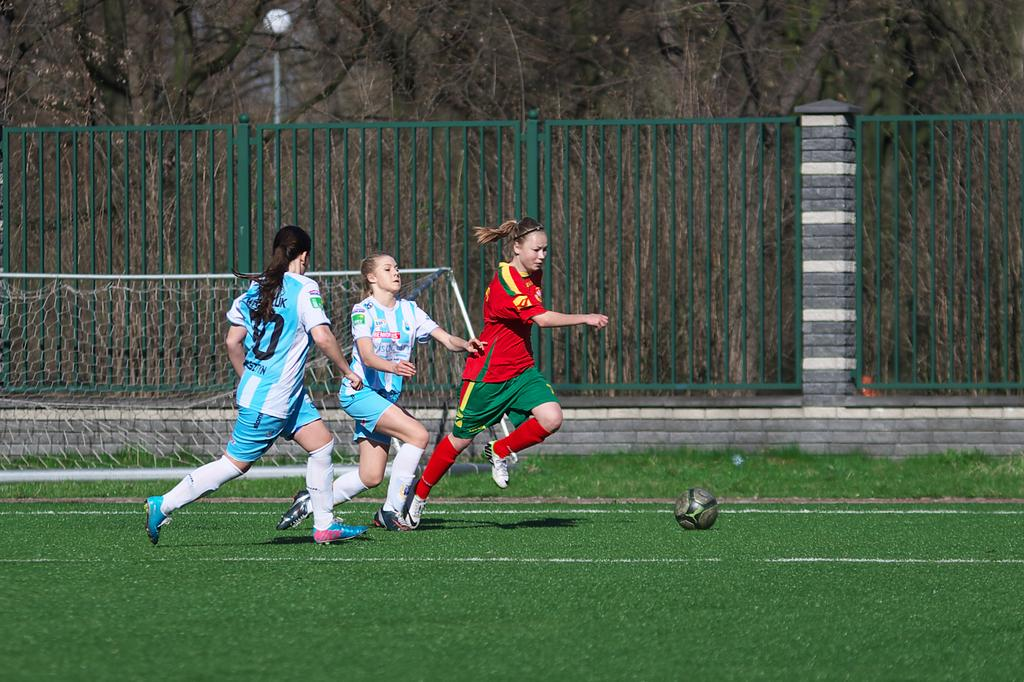<image>
Write a terse but informative summary of the picture. three girls playing soccer, one has blue shoes with nike in pink lettering 